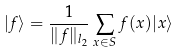Convert formula to latex. <formula><loc_0><loc_0><loc_500><loc_500>| f \rangle = \frac { 1 } { \| f \| _ { l _ { 2 } } } \sum _ { x \in S } f ( x ) | x \rangle</formula> 